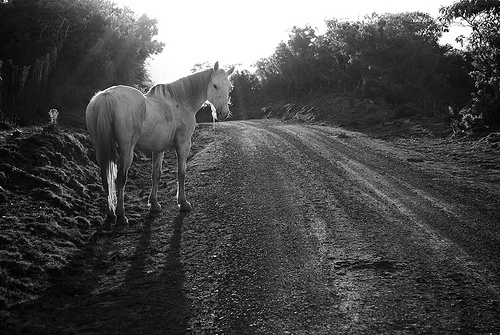Describe the objects in this image and their specific colors. I can see a horse in black, gray, and lightgray tones in this image. 